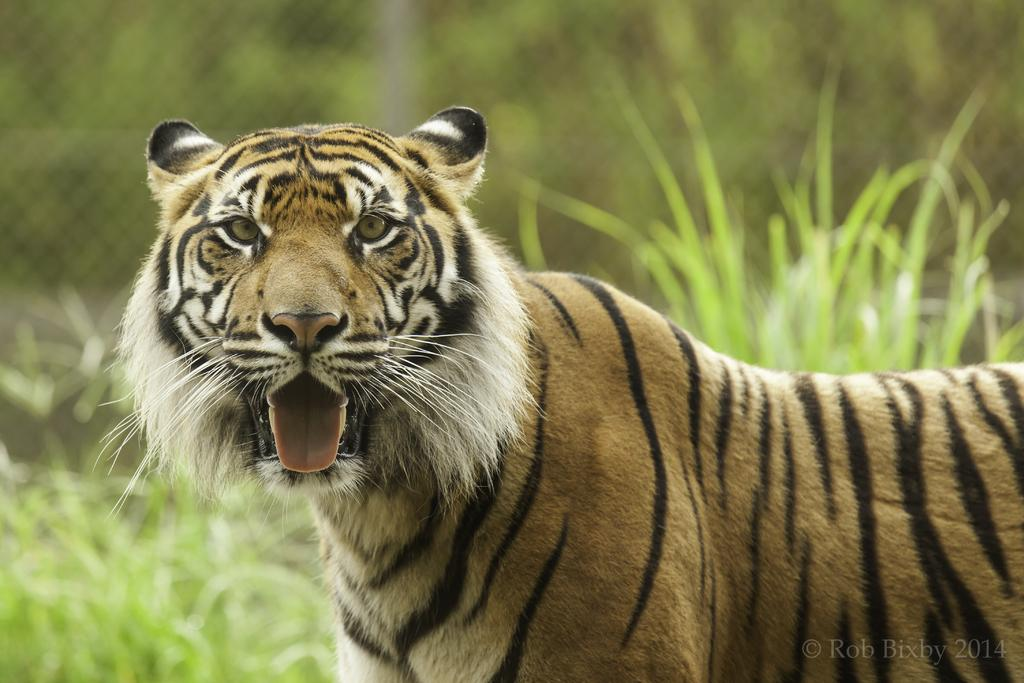What type of animal is in the image? There is a tiger in the image. What type of vegetation is present in the image? There is grass in the image. What type of barrier is visible in the image? There is a fence in the image. What type of discussion is taking place between the queen and the tiger in the image? There is no queen or discussion present in the image; it only features a tiger, grass, and a fence. 